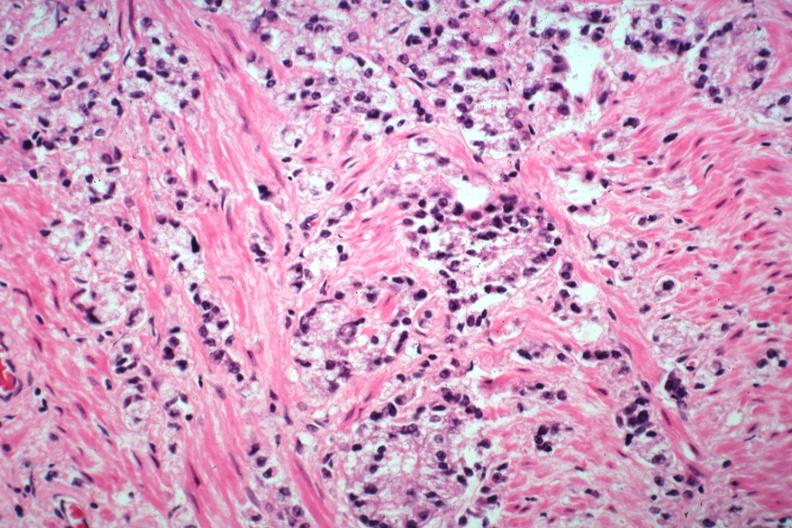s adenocarcinoma present?
Answer the question using a single word or phrase. Yes 